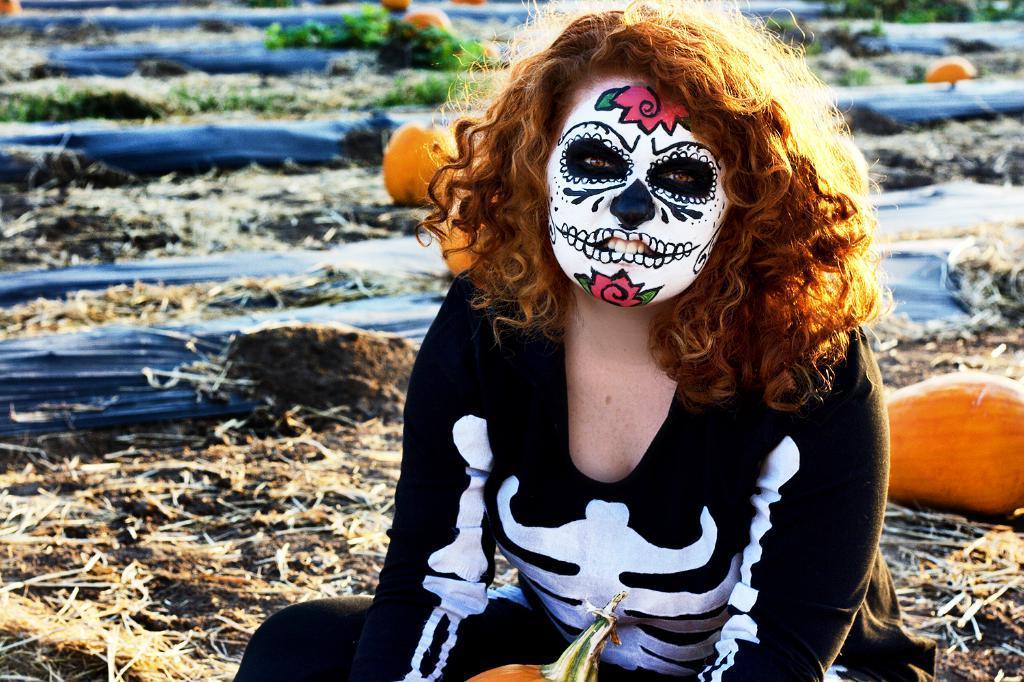Could you give a brief overview of what you see in this image? In this picture we can see a woman with a painting on her face and in the background we can see dried grass, plants, pumpkins and some objects. 